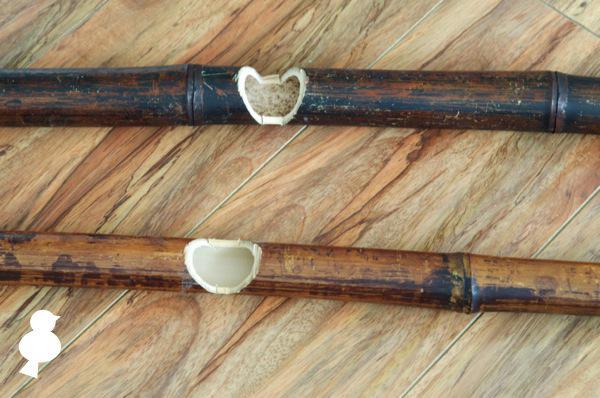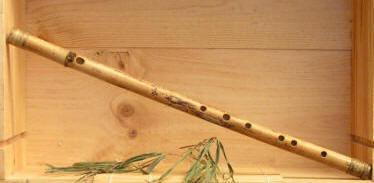The first image is the image on the left, the second image is the image on the right. Evaluate the accuracy of this statement regarding the images: "One image contains a single flute displayed diagonally, and the other image contains two items displayed horizontally, at least one a bamboo stick without a row of small holes on it.". Is it true? Answer yes or no. Yes. The first image is the image on the left, the second image is the image on the right. For the images shown, is this caption "There are three flutes in total." true? Answer yes or no. Yes. 